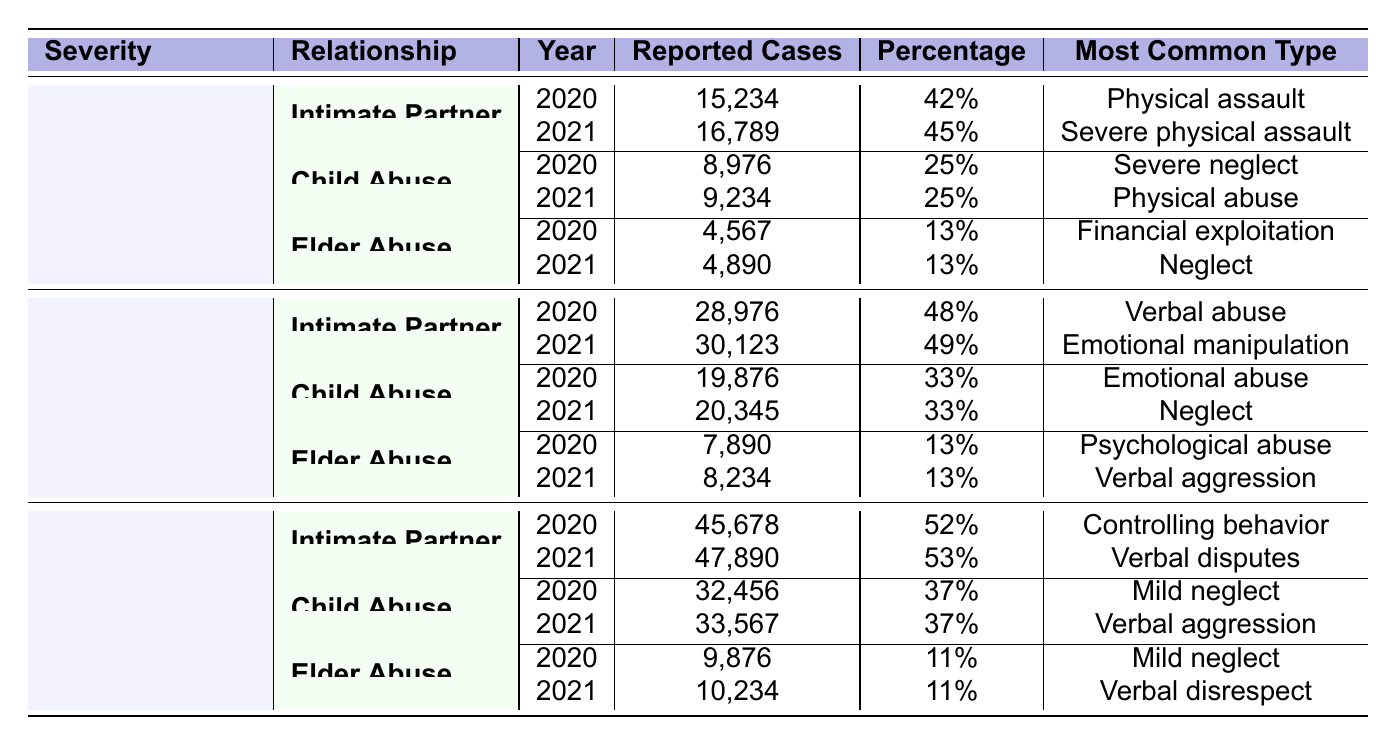What were the most reported cases of Intimate Partner Violence in 2020? The table shows that in 2020, the reported cases of Intimate Partner Violence were 15,234.
Answer: 15,234 What percentage of total reported cases were due to Child Abuse in 2021? In 2021, the percentage of total reported cases for Child Abuse is recorded as 25%.
Answer: 25% How many more reported cases of Elder Abuse were there in 2021 than in 2020? In 2021, the reported cases of Elder Abuse were 4,890 and in 2020, they were 4,567. The difference is calculated as 4,890 - 4,567 = 323.
Answer: 323 Which category had the highest reported cases for Moderate Cases in 2021? In 2021, the category for Moderate Cases with the highest reported cases is Intimate Partner Violence with 30,123 cases.
Answer: Intimate Partner Violence What is the sum of reported cases for Child Abuse across all severity levels in 2020? For Child Abuse in 2020, the reported cases are 8,976 for Severe Cases, 19,876 for Moderate Cases, and 32,456 for Minor Cases. The sum is 8,976 + 19,876 + 32,456 = 61,308.
Answer: 61,308 Is the most common type of abuse in Moderate Cases for Elder Abuse consistent between 2020 and 2021? In 2020, the most common type was Psychological abuse, while in 2021 it was Verbal aggression, indicating a change in the most common type.
Answer: No What percentage of total cases were reported as Minor Cases in 2021? For Minor Cases in 2021, the respective cases are 47,890 for Intimate Partner Violence, 33,567 for Child Abuse, and 10,234 for Elder Abuse. The total reported cases for all categories are 15,234 + 16,789 + 8,976 + 9,234 + 4,567 + 4,890 + 28,976 + 30,123 + 19,876 + 20,345 + 7,890 + 8,234 + 45,678 + 47,890 + 32,456 + 33,567 + 9,876 + 10,234 = 346,967. The percentage for Minor Cases is (47,890 + 33,567 + 10,234) / 346,967, which is approximately 23%.
Answer: 23% Which relationship type had the least reported cases in 2020 for Severe Cases? The table indicates that Elder Abuse had the least reported cases in 2020 for Severe Cases, with 4,567 cases.
Answer: Elder Abuse In which year did the reported cases for Intimate Partner Violence in Minor Cases increase the most? The reported cases in Minor Cases for Intimate Partner Violence were 45,678 in 2020 and 47,890 in 2021. The increase of 2,212 is calculated as 47,890 - 45,678.
Answer: 2021 What was the most common type of abuse in Minor Cases for Child Abuse in 2021? For Minor Cases in 2021, the most common type of abuse for Child Abuse is Verbal aggression, as stated in the table.
Answer: Verbal aggression 